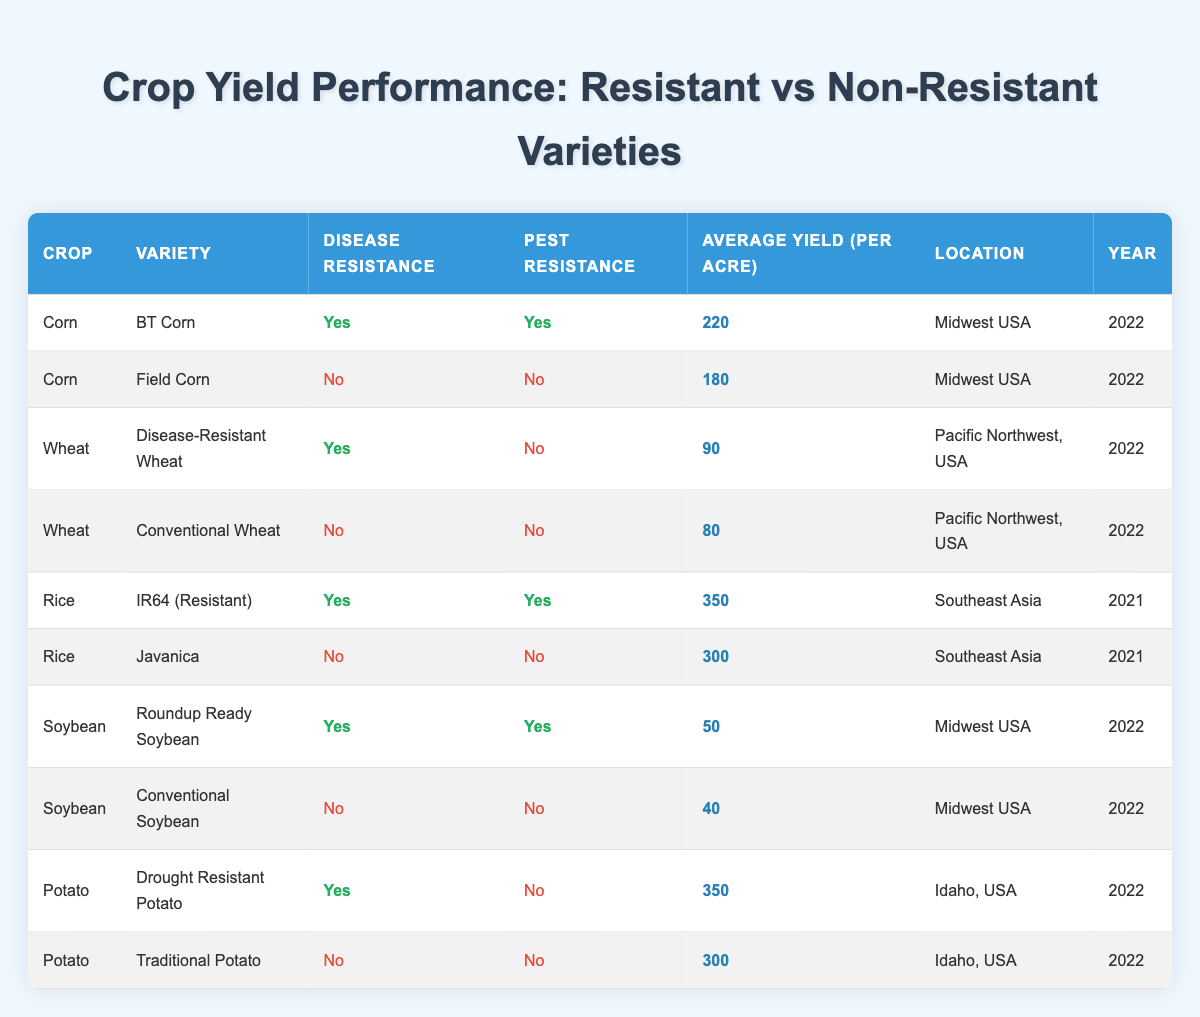What is the average yield of disease-resistant corn varieties? There are two disease-resistant corn varieties (BT Corn) with yields of 220 acres. The average yield is calculated by summing the yield (220) and dividing it by the number of varieties (1). Thus, 220/1 = 220.
Answer: 220 Which crop variety has the highest average yield per acre? The highest average yield per acre is found in the rice variety IR64, with an average yield of 350. This is determined by comparing the average yields from all listed crop varieties.
Answer: IR64 (Resistant) Is Disease-Resistant Wheat more productive than Conventional Wheat? The average yield of Disease-Resistant Wheat is 90 acres, while Conventional Wheat has an average yield of 80 acres. Since 90 is greater than 80, then yes, Disease-Resistant Wheat is more productive.
Answer: Yes What is the combined average yield of all disease-resistant soybean varieties? There is one disease-resistant soybean variety, Roundup Ready Soybean, with a yield of 50 acres. Since there is only one, the combined average yield is simply 50.
Answer: 50 Are there any crops with disease-resistant varieties that yield less than 100 acres? The disease-resistant wheat variety yields 90 acres, which is less than 100. Therefore, yes, there are crops with disease-resistant varieties that yield less than 100.
Answer: Yes How does the average yield of all disease-resistant crops compare to that of non-resistant crops? There are 5 disease-resistant crops with yields of 220 (Corn), 90 (Wheat), 350 (Rice), 50 (Soybean), and 350 (Potato). Their total yield is 220 + 90 + 350 + 50 + 350 = 1060; averaging this yields 1060/5 = 212. For non-resistant, the yields are 180 (Corn), 80 (Wheat), 300 (Rice), 40 (Soybean), and 300 (Potato), totaling 900 with an average of 900/5 = 180. Since 212 > 180, disease-resistant crops yield more on average.
Answer: Disease-resistant varieties yield more Which crop has the lowest average yield among the non-resistant varieties? The conventional soybean variety has an average yield of 40 acres, which is lower than any other non-resistant crop (which are 180, 80, 300, and 300 for Corn, Wheat, Rice, and Potato respectively).
Answer: Conventional Soybean 